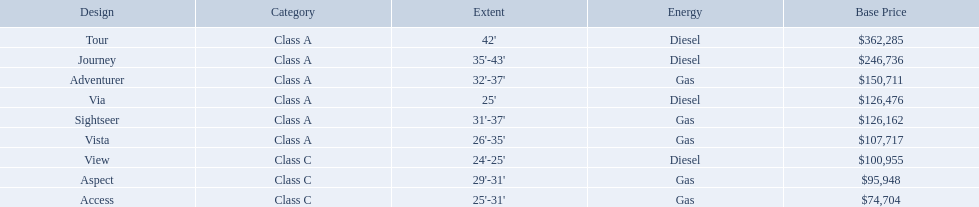Which models are manufactured by winnebago industries? Tour, Journey, Adventurer, Via, Sightseer, Vista, View, Aspect, Access. What type of fuel does each model require? Diesel, Diesel, Gas, Diesel, Gas, Gas, Diesel, Gas, Gas. And between the tour and aspect, which runs on diesel? Tour. What are all of the winnebago models? Tour, Journey, Adventurer, Via, Sightseer, Vista, View, Aspect, Access. What are their prices? $362,285, $246,736, $150,711, $126,476, $126,162, $107,717, $100,955, $95,948, $74,704. And which model costs the most? Tour. 